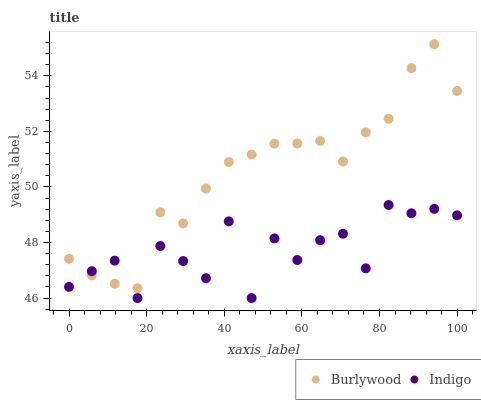Does Indigo have the minimum area under the curve?
Answer yes or no. Yes. Does Burlywood have the maximum area under the curve?
Answer yes or no. Yes. Does Indigo have the maximum area under the curve?
Answer yes or no. No. Is Burlywood the smoothest?
Answer yes or no. Yes. Is Indigo the roughest?
Answer yes or no. Yes. Is Indigo the smoothest?
Answer yes or no. No. Does Indigo have the lowest value?
Answer yes or no. Yes. Does Burlywood have the highest value?
Answer yes or no. Yes. Does Indigo have the highest value?
Answer yes or no. No. Does Burlywood intersect Indigo?
Answer yes or no. Yes. Is Burlywood less than Indigo?
Answer yes or no. No. Is Burlywood greater than Indigo?
Answer yes or no. No. 